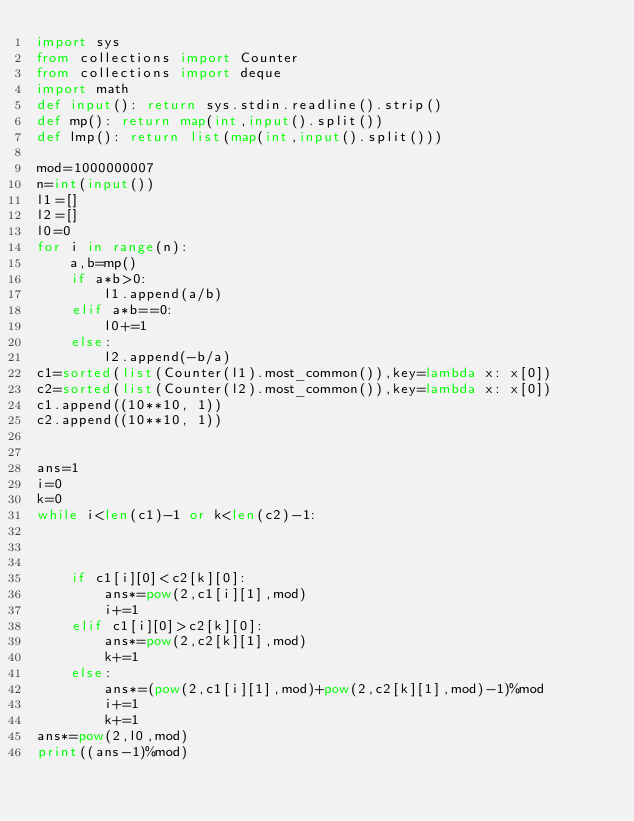<code> <loc_0><loc_0><loc_500><loc_500><_Python_>import sys
from collections import Counter
from collections import deque
import math
def input(): return sys.stdin.readline().strip()
def mp(): return map(int,input().split())
def lmp(): return list(map(int,input().split()))

mod=1000000007
n=int(input())
l1=[]
l2=[]
l0=0
for i in range(n):
    a,b=mp()
    if a*b>0:
        l1.append(a/b)
    elif a*b==0:
        l0+=1
    else:
        l2.append(-b/a)
c1=sorted(list(Counter(l1).most_common()),key=lambda x: x[0])
c2=sorted(list(Counter(l2).most_common()),key=lambda x: x[0])
c1.append((10**10, 1))
c2.append((10**10, 1))


ans=1
i=0
k=0
while i<len(c1)-1 or k<len(c2)-1:



    if c1[i][0]<c2[k][0]:
        ans*=pow(2,c1[i][1],mod)
        i+=1
    elif c1[i][0]>c2[k][0]:
        ans*=pow(2,c2[k][1],mod)
        k+=1
    else:
        ans*=(pow(2,c1[i][1],mod)+pow(2,c2[k][1],mod)-1)%mod
        i+=1
        k+=1
ans*=pow(2,l0,mod)
print((ans-1)%mod)</code> 